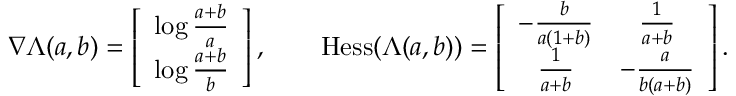<formula> <loc_0><loc_0><loc_500><loc_500>\begin{array} { r } { \nabla \Lambda ( a , b ) = \left [ \begin{array} { c } { \log \frac { a + b } { a } } \\ { \log \frac { a + b } { b } } \end{array} \right ] , \quad H e s s ( \Lambda ( a , b ) ) = \left [ \begin{array} { c c } { - \frac { b } { a ( 1 + b ) } } & { \frac { 1 } { a + b } } \\ { \frac { 1 } { a + b } } & { - \frac { a } { b ( a + b ) } } \end{array} \right ] . } \end{array}</formula> 